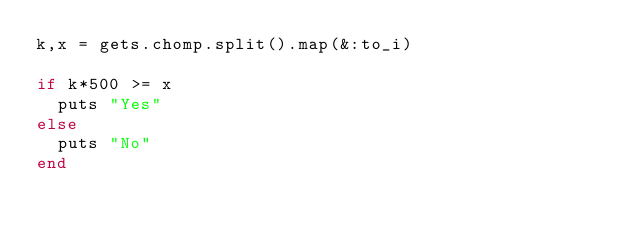Convert code to text. <code><loc_0><loc_0><loc_500><loc_500><_Ruby_>k,x = gets.chomp.split().map(&:to_i)

if k*500 >= x
  puts "Yes"
else
  puts "No"
end</code> 